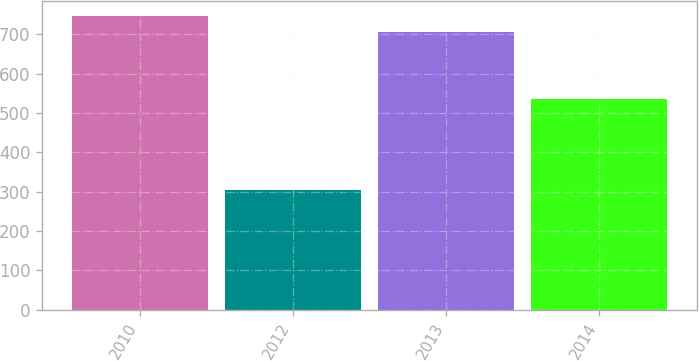Convert chart to OTSL. <chart><loc_0><loc_0><loc_500><loc_500><bar_chart><fcel>2010<fcel>2012<fcel>2013<fcel>2014<nl><fcel>747.6<fcel>305<fcel>705<fcel>536<nl></chart> 